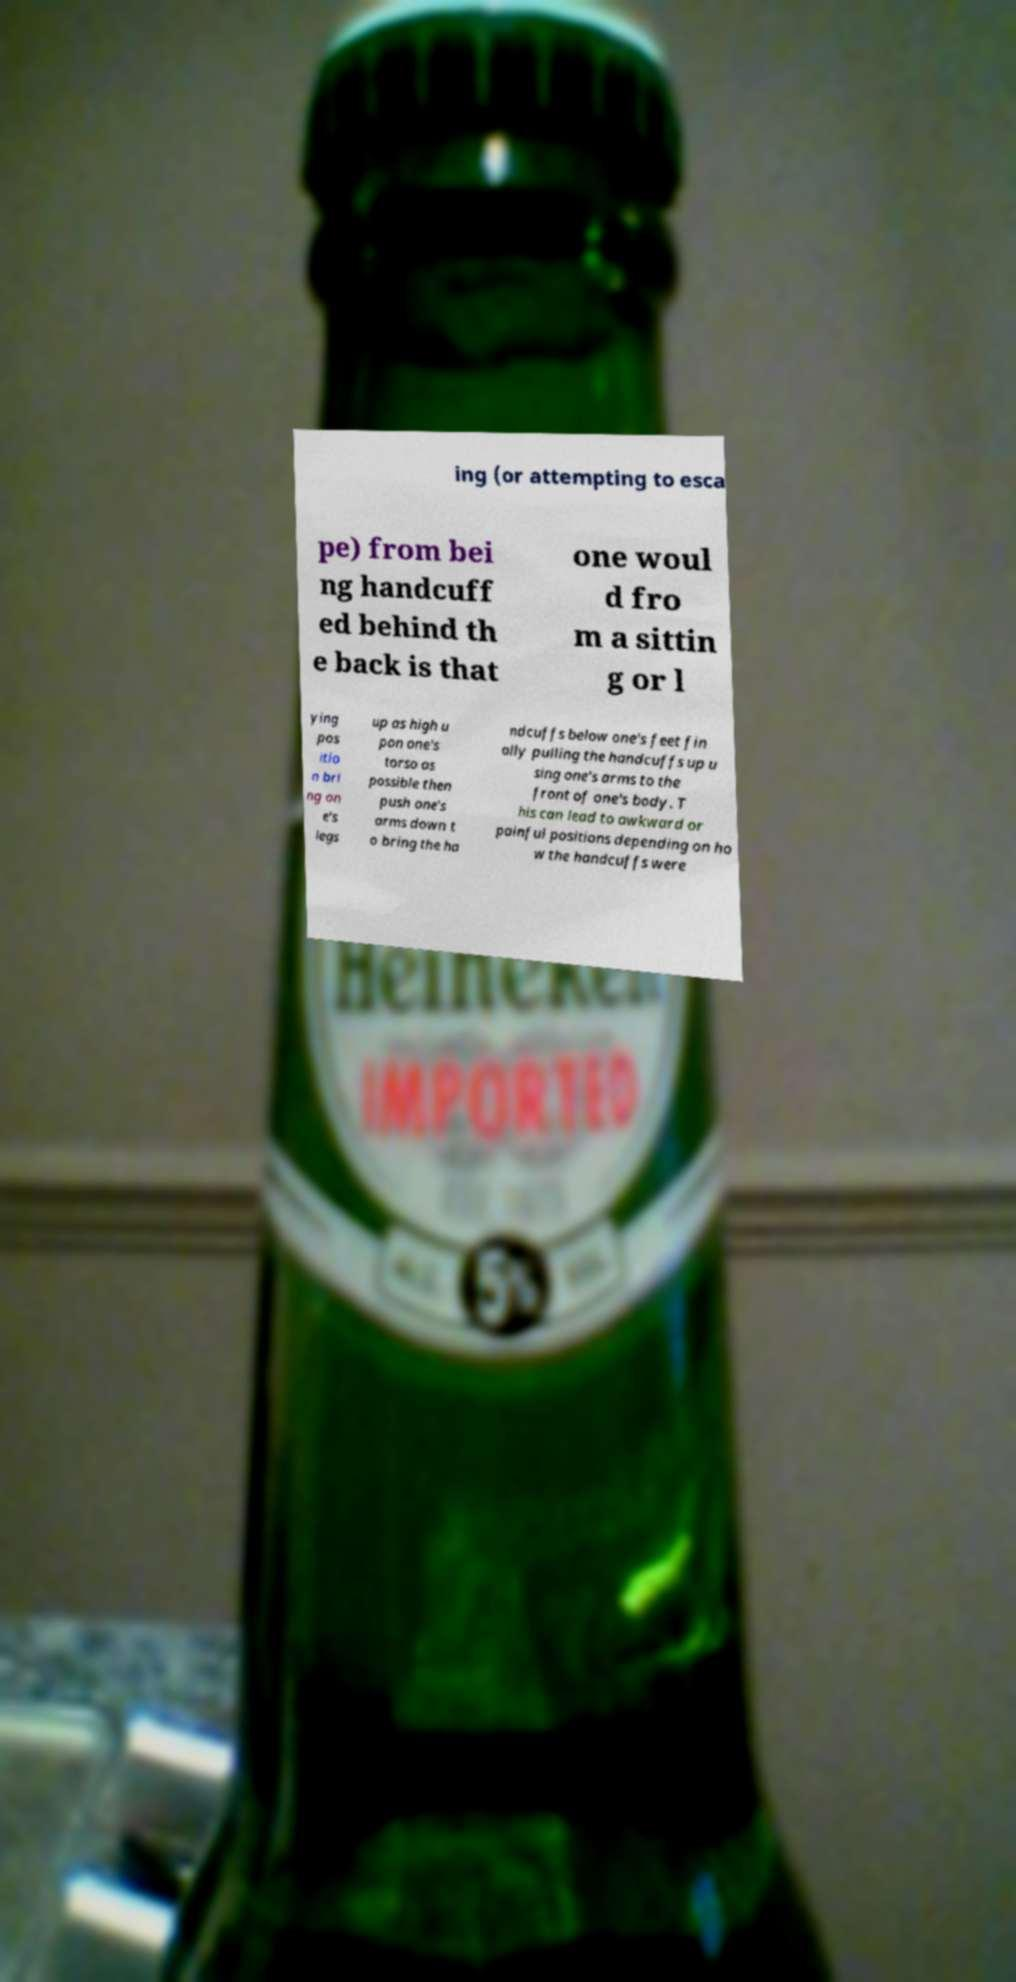For documentation purposes, I need the text within this image transcribed. Could you provide that? ing (or attempting to esca pe) from bei ng handcuff ed behind th e back is that one woul d fro m a sittin g or l ying pos itio n bri ng on e's legs up as high u pon one's torso as possible then push one's arms down t o bring the ha ndcuffs below one's feet fin ally pulling the handcuffs up u sing one's arms to the front of one's body. T his can lead to awkward or painful positions depending on ho w the handcuffs were 